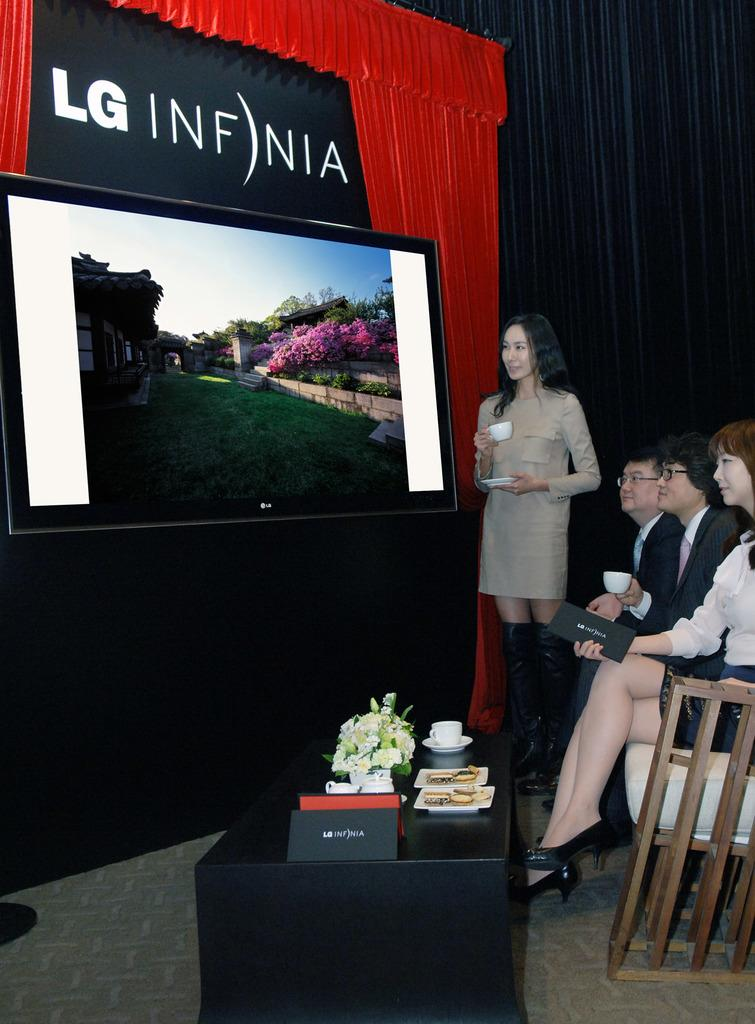<image>
Offer a succinct explanation of the picture presented. A woman is drinking from a tea cup while standing next to an LG branded television. 